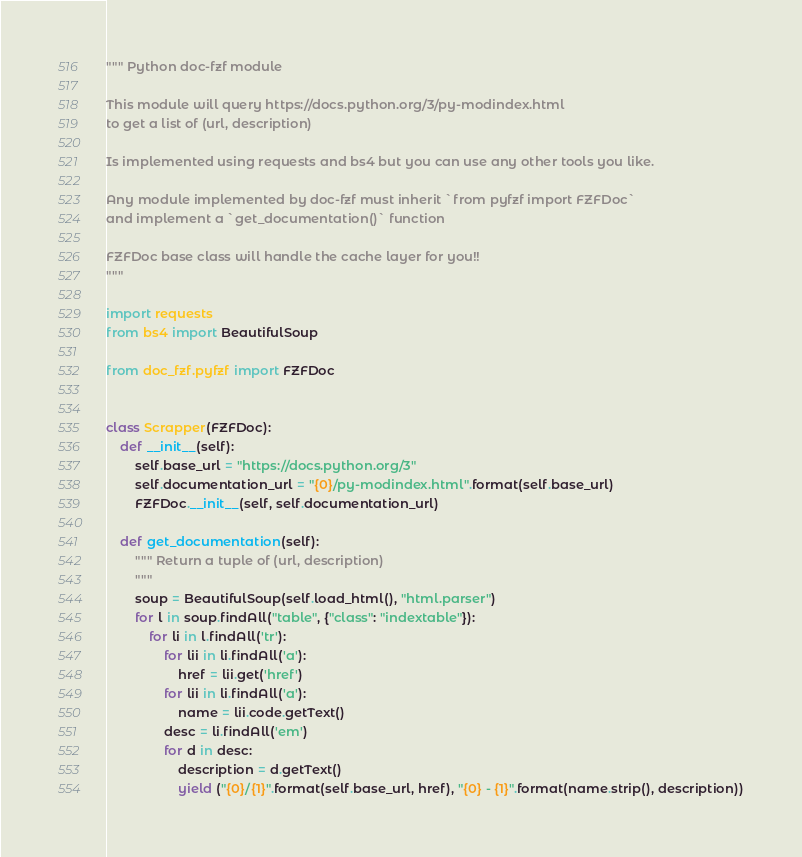Convert code to text. <code><loc_0><loc_0><loc_500><loc_500><_Python_>""" Python doc-fzf module

This module will query https://docs.python.org/3/py-modindex.html
to get a list of (url, description)

Is implemented using requests and bs4 but you can use any other tools you like.

Any module implemented by doc-fzf must inherit `from pyfzf import FZFDoc`
and implement a `get_documentation()` function

FZFDoc base class will handle the cache layer for you!!
"""

import requests
from bs4 import BeautifulSoup

from doc_fzf.pyfzf import FZFDoc


class Scrapper(FZFDoc):
    def __init__(self):
        self.base_url = "https://docs.python.org/3"
        self.documentation_url = "{0}/py-modindex.html".format(self.base_url)
        FZFDoc.__init__(self, self.documentation_url)

    def get_documentation(self):
        """ Return a tuple of (url, description)
        """
        soup = BeautifulSoup(self.load_html(), "html.parser")
        for l in soup.findAll("table", {"class": "indextable"}):
            for li in l.findAll('tr'):
                for lii in li.findAll('a'):
                    href = lii.get('href')
                for lii in li.findAll('a'):
                    name = lii.code.getText()
                desc = li.findAll('em')
                for d in desc:
                    description = d.getText()
                    yield ("{0}/{1}".format(self.base_url, href), "{0} - {1}".format(name.strip(), description))
</code> 